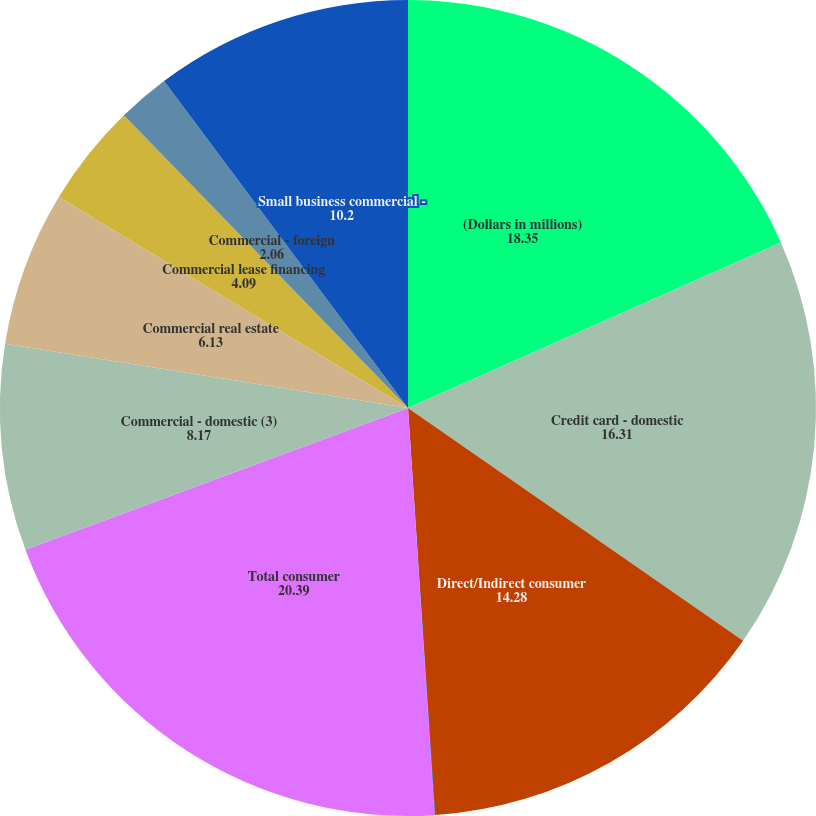Convert chart. <chart><loc_0><loc_0><loc_500><loc_500><pie_chart><fcel>(Dollars in millions)<fcel>Credit card - domestic<fcel>Direct/Indirect consumer<fcel>Other consumer<fcel>Total consumer<fcel>Commercial - domestic (3)<fcel>Commercial real estate<fcel>Commercial lease financing<fcel>Commercial - foreign<fcel>Small business commercial -<nl><fcel>18.35%<fcel>16.31%<fcel>14.28%<fcel>0.02%<fcel>20.39%<fcel>8.17%<fcel>6.13%<fcel>4.09%<fcel>2.06%<fcel>10.2%<nl></chart> 